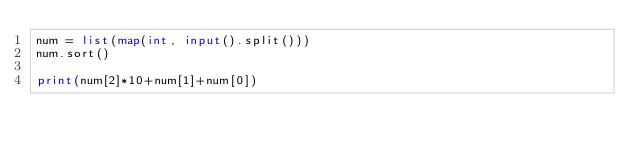<code> <loc_0><loc_0><loc_500><loc_500><_Python_>num = list(map(int, input().split()))
num.sort()

print(num[2]*10+num[1]+num[0])</code> 